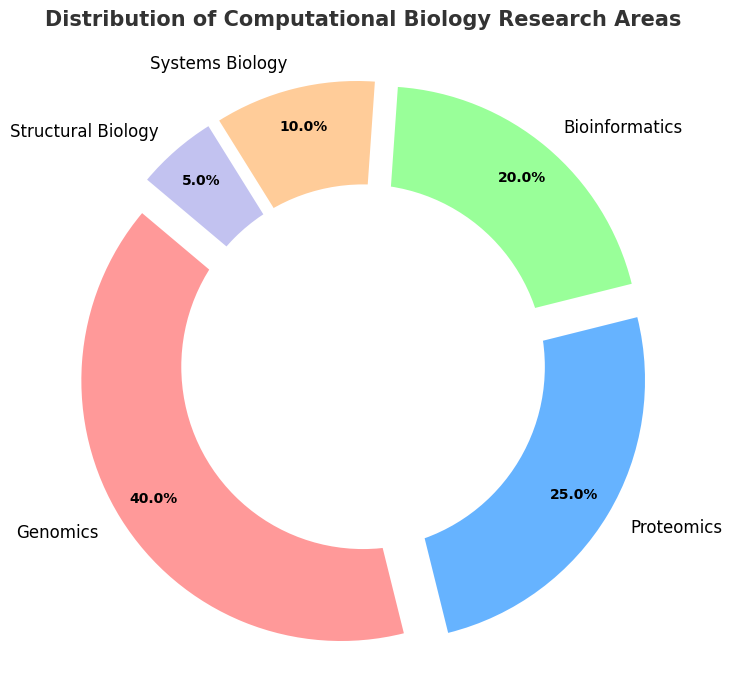What percentage of research areas does Genomics cover? The pie chart shows the percentage for each research area. Genomics, identified by its label, covers 40%.
Answer: 40% Which research area occupies the smallest portion of the pie chart? The smallest portion can be visually identified as the smallest segment of the pie chart, which is Structural Biology at 5%.
Answer: Structural Biology What is the combined percentage of Proteomics and Bioinformatics? Add the percentages of Proteomics (25%) and Bioinformatics (20%). 25% + 20% = 45%.
Answer: 45% How do the percentages of Genomics and Systems Biology compare? Genomics is 40% and Systems Biology is 10%. 40% is 30% greater than 10%.
Answer: Genomics is 30% greater If Systems Biology and Structural Biology were combined, what percentage of the total would they represent? Add the percentages of Systems Biology (10%) and Structural Biology (5%). 10% + 5% = 15%.
Answer: 15% Which research area has a percentage closest to 20%? The pie chart shows that Bioinformatics has a percentage of 20%, which is closest to 20%.
Answer: Bioinformatics Rank the research areas from the highest to the lowest percentage. By examining the percentages: Genomics (40%), Proteomics (25%), Bioinformatics (20%), Systems Biology (10%), Structural Biology (5%).
Answer: Genomics, Proteomics, Bioinformatics, Systems Biology, Structural Biology What is the average percentage of all research areas? Sum the percentages (40% + 25% + 20% + 10% + 5% = 100%) and divide by the number of areas (5). Average = 100% / 5 = 20%.
Answer: 20% What is the difference in percentage points between the largest and smallest research areas? The largest area is Genomics (40%) and the smallest is Structural Biology (5%). Difference = 40% - 5% = 35%.
Answer: 35% Which research area occupies the green segment of the pie chart? By reviewing the standard color palette used (red, blue, green, etc.), Bioinformatics is represented by green.
Answer: Bioinformatics 